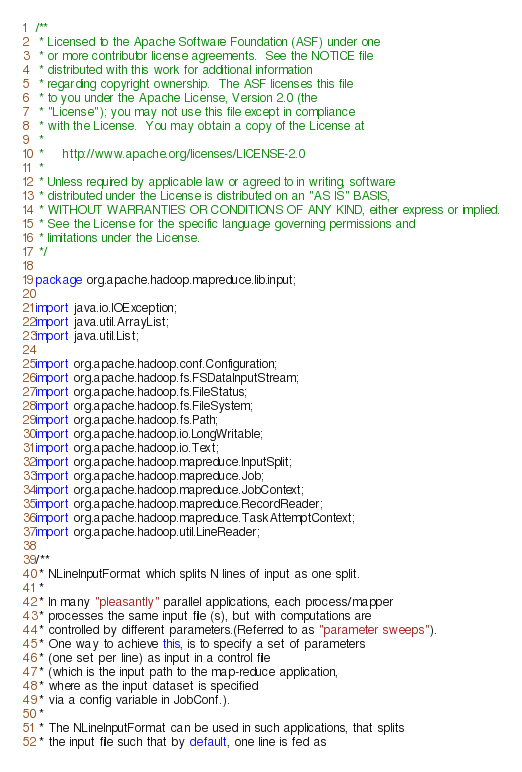<code> <loc_0><loc_0><loc_500><loc_500><_Java_>/**
 * Licensed to the Apache Software Foundation (ASF) under one
 * or more contributor license agreements.  See the NOTICE file
 * distributed with this work for additional information
 * regarding copyright ownership.  The ASF licenses this file
 * to you under the Apache License, Version 2.0 (the
 * "License"); you may not use this file except in compliance
 * with the License.  You may obtain a copy of the License at
 *
 *     http://www.apache.org/licenses/LICENSE-2.0
 *
 * Unless required by applicable law or agreed to in writing, software
 * distributed under the License is distributed on an "AS IS" BASIS,
 * WITHOUT WARRANTIES OR CONDITIONS OF ANY KIND, either express or implied.
 * See the License for the specific language governing permissions and
 * limitations under the License.
 */

package org.apache.hadoop.mapreduce.lib.input;

import java.io.IOException;
import java.util.ArrayList;
import java.util.List;

import org.apache.hadoop.conf.Configuration;
import org.apache.hadoop.fs.FSDataInputStream;
import org.apache.hadoop.fs.FileStatus;
import org.apache.hadoop.fs.FileSystem;
import org.apache.hadoop.fs.Path;
import org.apache.hadoop.io.LongWritable;
import org.apache.hadoop.io.Text;
import org.apache.hadoop.mapreduce.InputSplit;
import org.apache.hadoop.mapreduce.Job;
import org.apache.hadoop.mapreduce.JobContext;
import org.apache.hadoop.mapreduce.RecordReader;
import org.apache.hadoop.mapreduce.TaskAttemptContext;
import org.apache.hadoop.util.LineReader;

/**
 * NLineInputFormat which splits N lines of input as one split.
 *
 * In many "pleasantly" parallel applications, each process/mapper 
 * processes the same input file (s), but with computations are 
 * controlled by different parameters.(Referred to as "parameter sweeps").
 * One way to achieve this, is to specify a set of parameters 
 * (one set per line) as input in a control file 
 * (which is the input path to the map-reduce application,
 * where as the input dataset is specified 
 * via a config variable in JobConf.).
 * 
 * The NLineInputFormat can be used in such applications, that splits 
 * the input file such that by default, one line is fed as</code> 